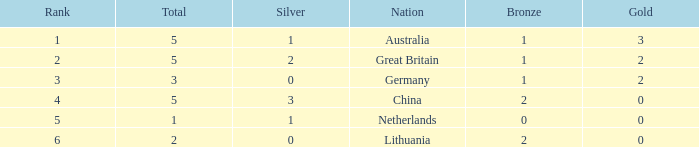What's the mean of silver when bronze is below 1 and gold is greater than 0? None. 